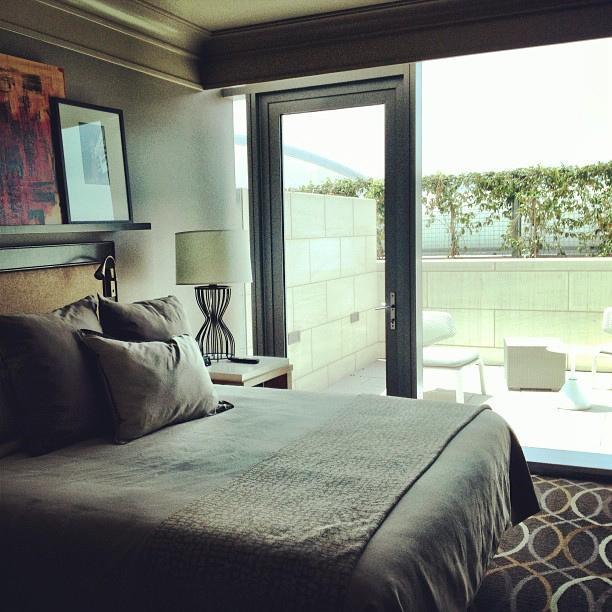How many people are laying down?
Give a very brief answer. 0. How many chairs are visible?
Give a very brief answer. 1. 